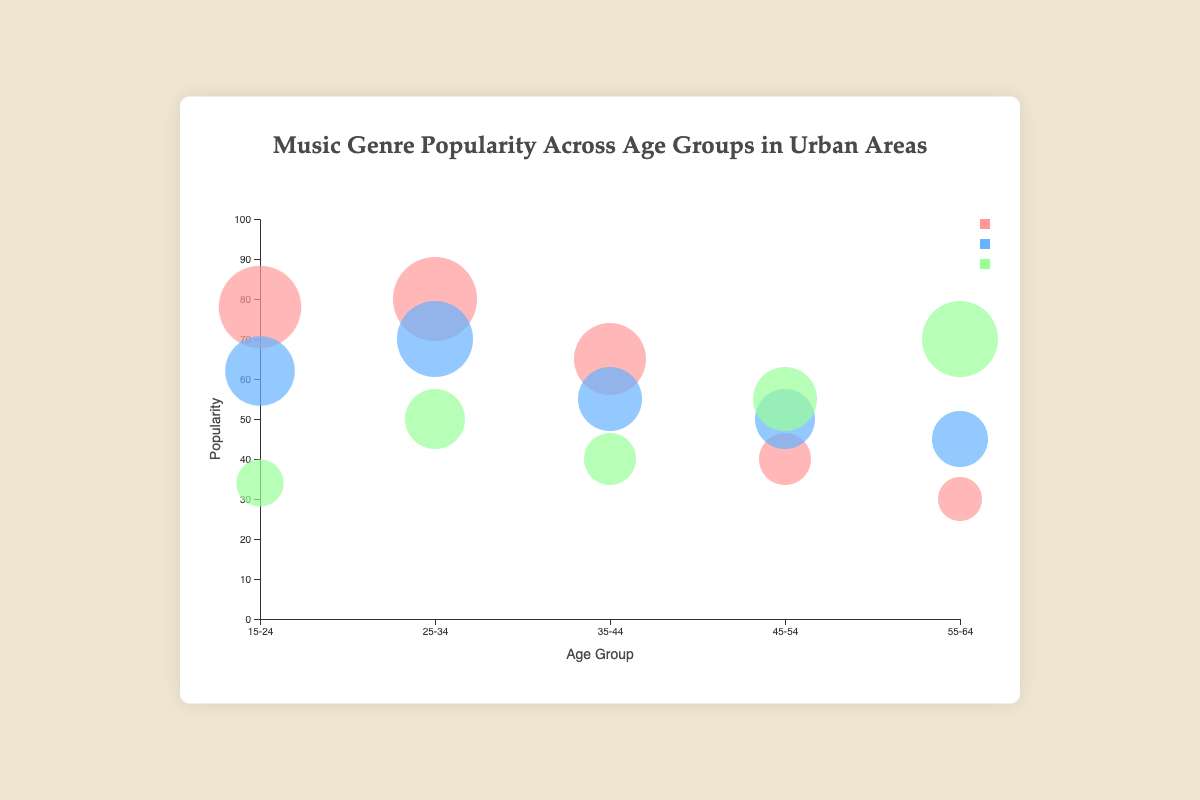What is the title of the bubble chart? The title is usually positioned at the top of the chart and written in a larger font size for visibility. The title of this chart is displayed in the centered text above the chart area.
Answer: Music Genre Popularity Across Age Groups in Urban Areas Which city shows the highest popularity for the 'Pop' genre? To answer this question, look for the largest bubble colored in the 'Pop' genre's designated color and then identify its city from the tooltip information.
Answer: Los Angeles How does the popularity of 'Classical' music in the 45-54 age group compare to the same genre in the 25-34 age group? Locate the bubbles representing 'Classical' music for the 45-54 and 25-34 age groups and compare their sizes, which denote popularity.
Answer: Higher in 45-54 What is the average popularity of 'Rock' music across all age groups? Identify and sum the popularity values of 'Rock' music for each age group and then divide by the number of age groups. The values are 62, 70, 55, 50, and 45. (62+70+55+50+45)/5 = 56.4.
Answer: 56.4 In which age group is 'Pop' music less popular than 'Rock' music? Compare the sizes of 'Pop' and 'Rock' genre bubbles within each age group. Observe where the 'Rock' bubble is larger than the 'Pop' bubble.
Answer: 45-54, 55-64 Which genre has the highest popularity in the 15-24 age group? Compare the sizes of the bubbles for 'Pop', 'Rock', and 'Classical' within the 15-24 age group. The largest bubble represents the highest popularity.
Answer: Pop What is the difference in popularity between 'Pop' and 'Classical' music in the 25-34 age group? For the 25-34 age group, find the popularity values for 'Pop' and 'Classical' music (80 and 50 respectively) and compute their difference: 80 - 50 = 30.
Answer: 30 How many age groups have 'Classical' music as the most popular genre? For each age group, check which genre bubble is the largest and count the age groups where 'Classical' is the largest.
Answer: 2 Which city has the lowest popularity for 'Rock' music? Review the bubbles for 'Rock' music in each city and identify the city with the smallest bubble. The popularity values for 'Rock' are New York (62), Los Angeles (70), Chicago (55), Houston (50), and San Francisco (45).
Answer: San Francisco 